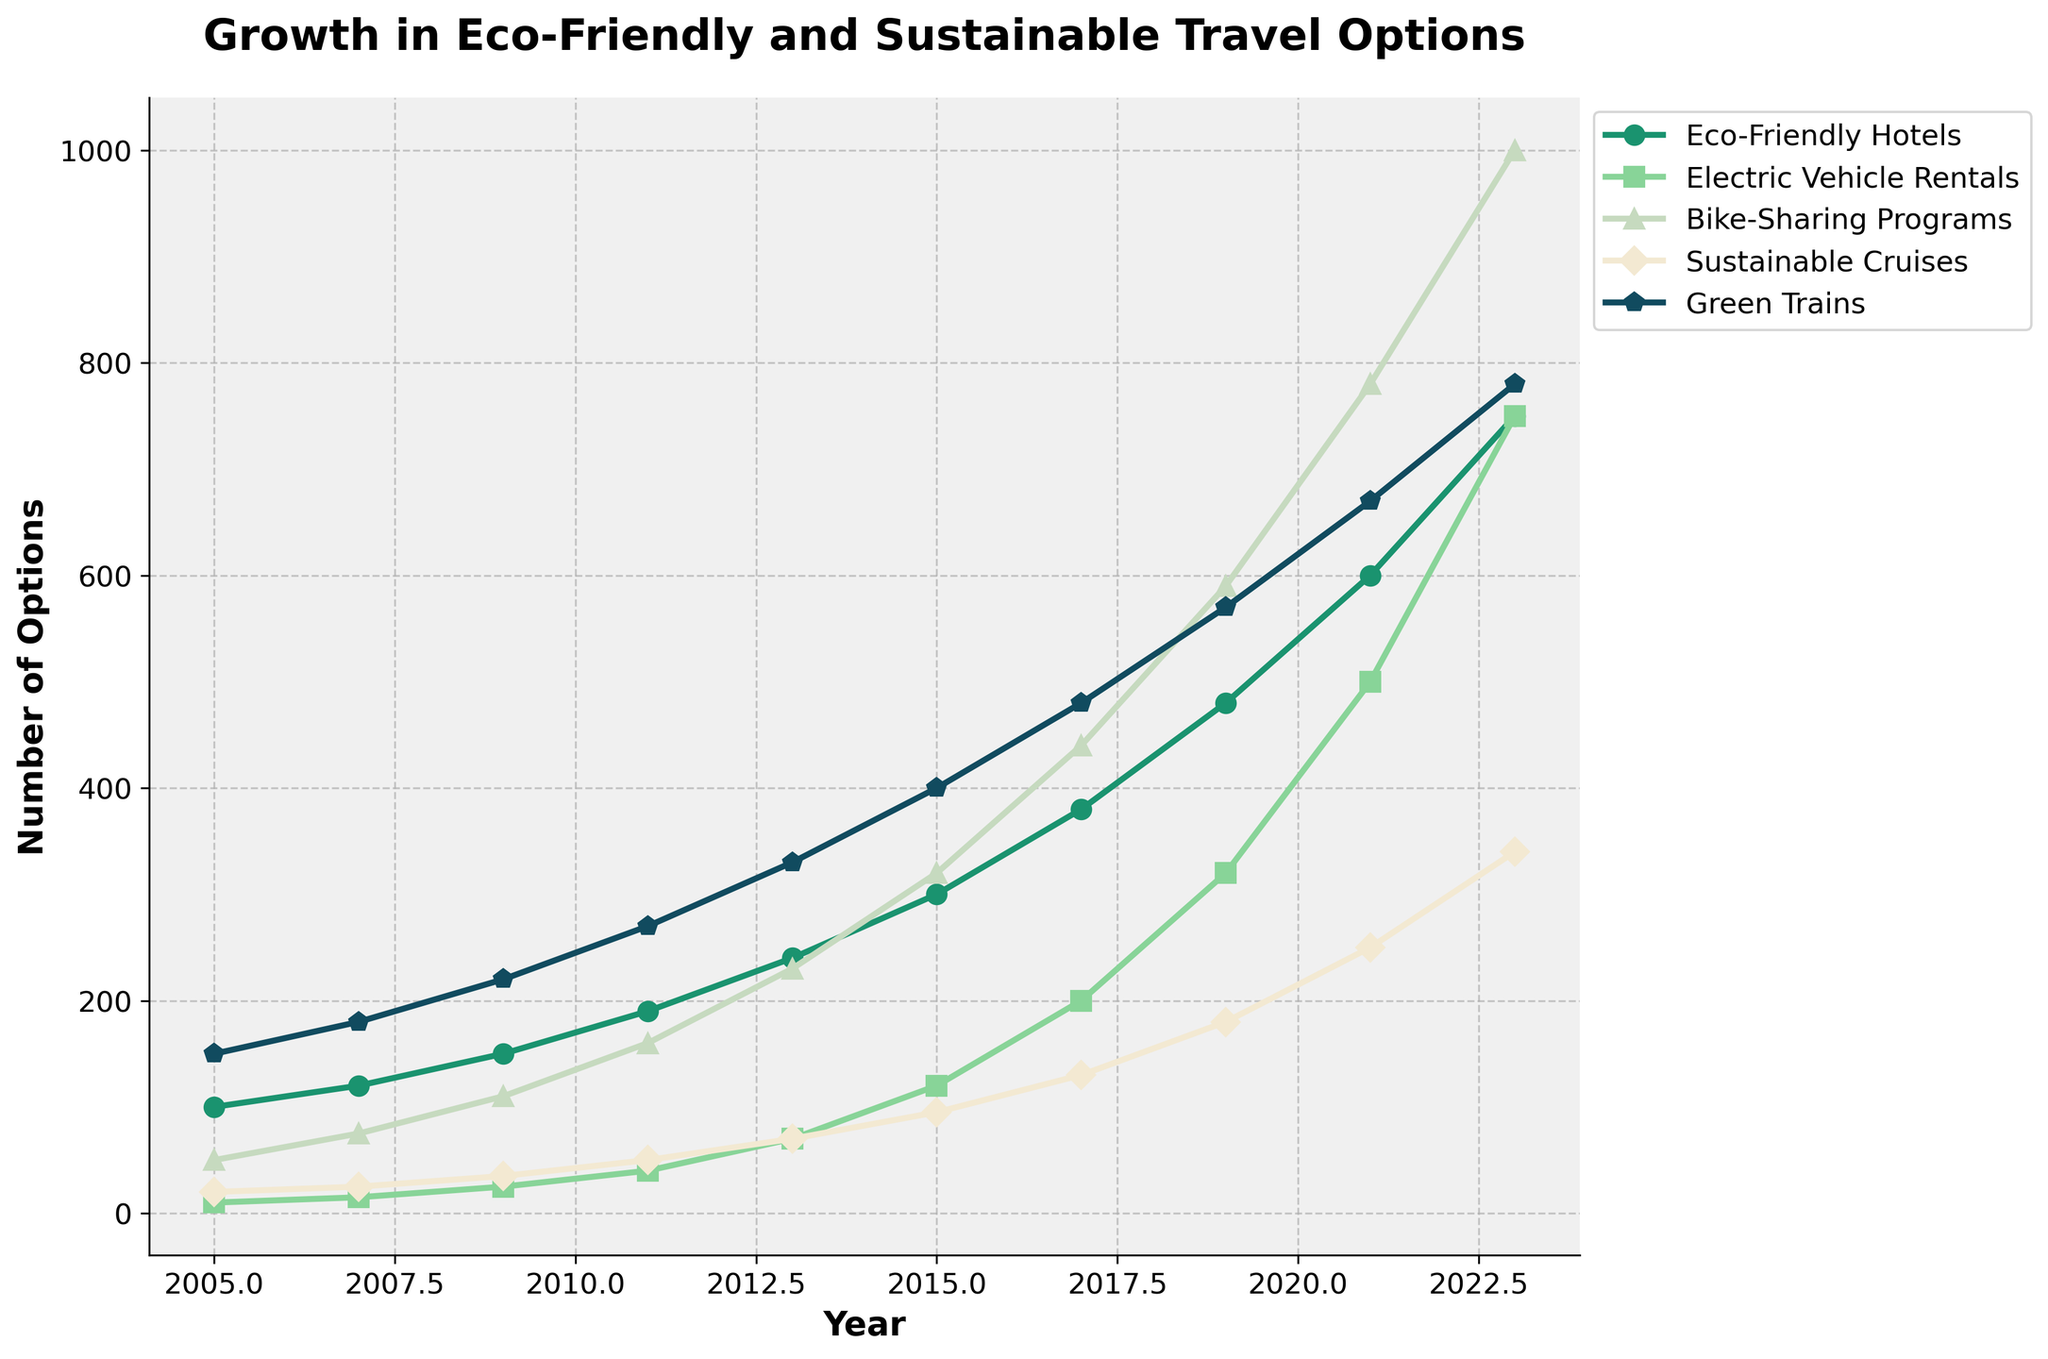What transportation option saw the most significant growth from 2005 to 2023? By visually comparing the height of the lines from 2005 to 2023, you'll notice that the Eco-Friendly Hotels option increased from 100 to 750. This is a growth of 650 options.
Answer: Eco-Friendly Hotels Between 2011 and 2017, which two transportation types had the highest increase in their number of options? Subtract the 2011 values from the 2017 values for each type and compare the differences. Electric Vehicle Rentals increased from 40 to 200 (increase of 160), and Bike-Sharing Programs increased from 160 to 440 (increase of 280).
Answer: Electric Vehicle Rentals and Bike-Sharing Programs What was the total number of eco-friendly and sustainable travel options available in 2019 across all categories? Add the number of options for each category in 2019: 480 (Eco-Friendly Hotels) + 320 (Electric Vehicle Rentals) + 590 (Bike-Sharing Programs) + 180 (Sustainable Cruises) + 570 (Green Trains). This equals 2140 options.
Answer: 2140 Which eco-friendly travel option surpassed 500 for the first time in 2021? Identify which line first crosses the 500 mark in 2021 by checking the values in the graph: both Electric Vehicle Rentals (500) and Bike-Sharing Programs (780) surpassed 500 in 2021.
Answer: Electric Vehicle Rentals and Bike-Sharing Programs Was there any transportation type that showed a linear growth trend from 2005 to 2023? A linear growth trend means a consistent increase over the years. By looking at the lines on the graph, the Green Trains line shows a relatively consistent slope, indicating linear growth.
Answer: Green Trains Which transportation type had the smallest increase from 2015 to 2023? By comparing the 2015 and 2023 values, Sustainable Cruises increased from 95 to 340, which is the smallest increase of 245 options.
Answer: Sustainable Cruises 